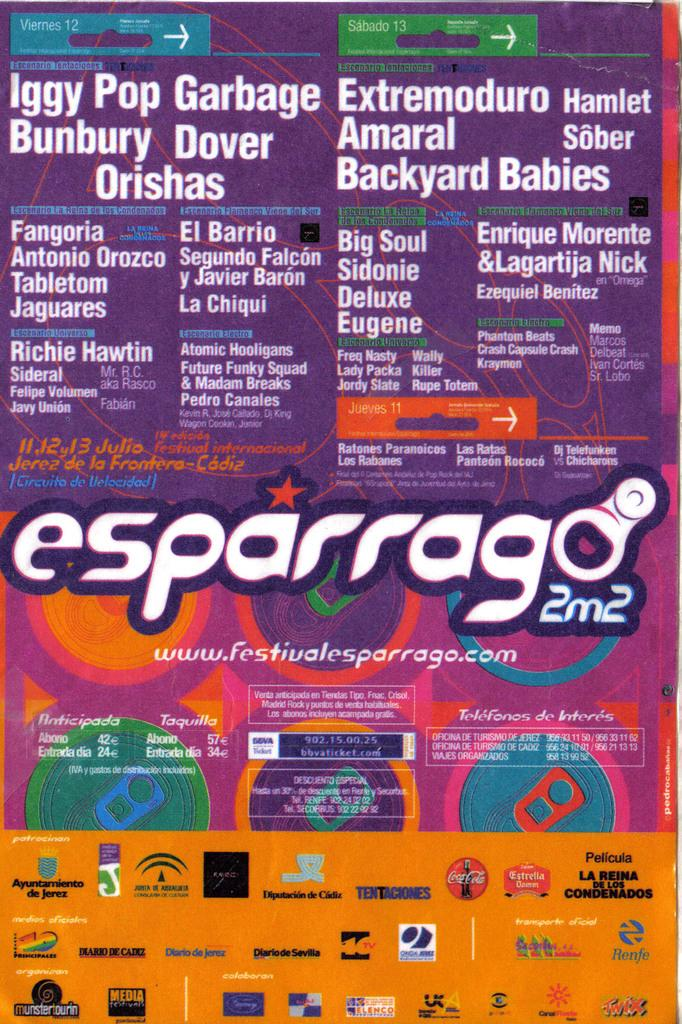<image>
Create a compact narrative representing the image presented. A colorful cluttered flyer advertising Esparrago 2m2 festival. 